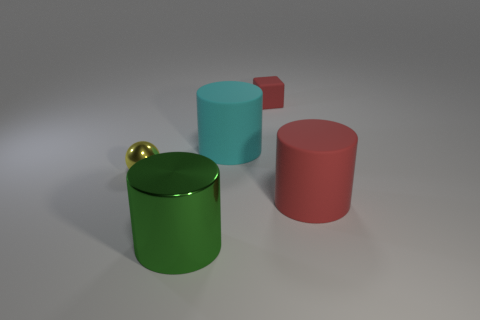Does the composition of this image seem to follow any artistic principles? Yes, the image employs the rule of thirds, as the objects are placed at intersection points, creating a balanced composition. The varying heights and colors also add visual interest, while the negative space ensures the scene isn't cluttered. 